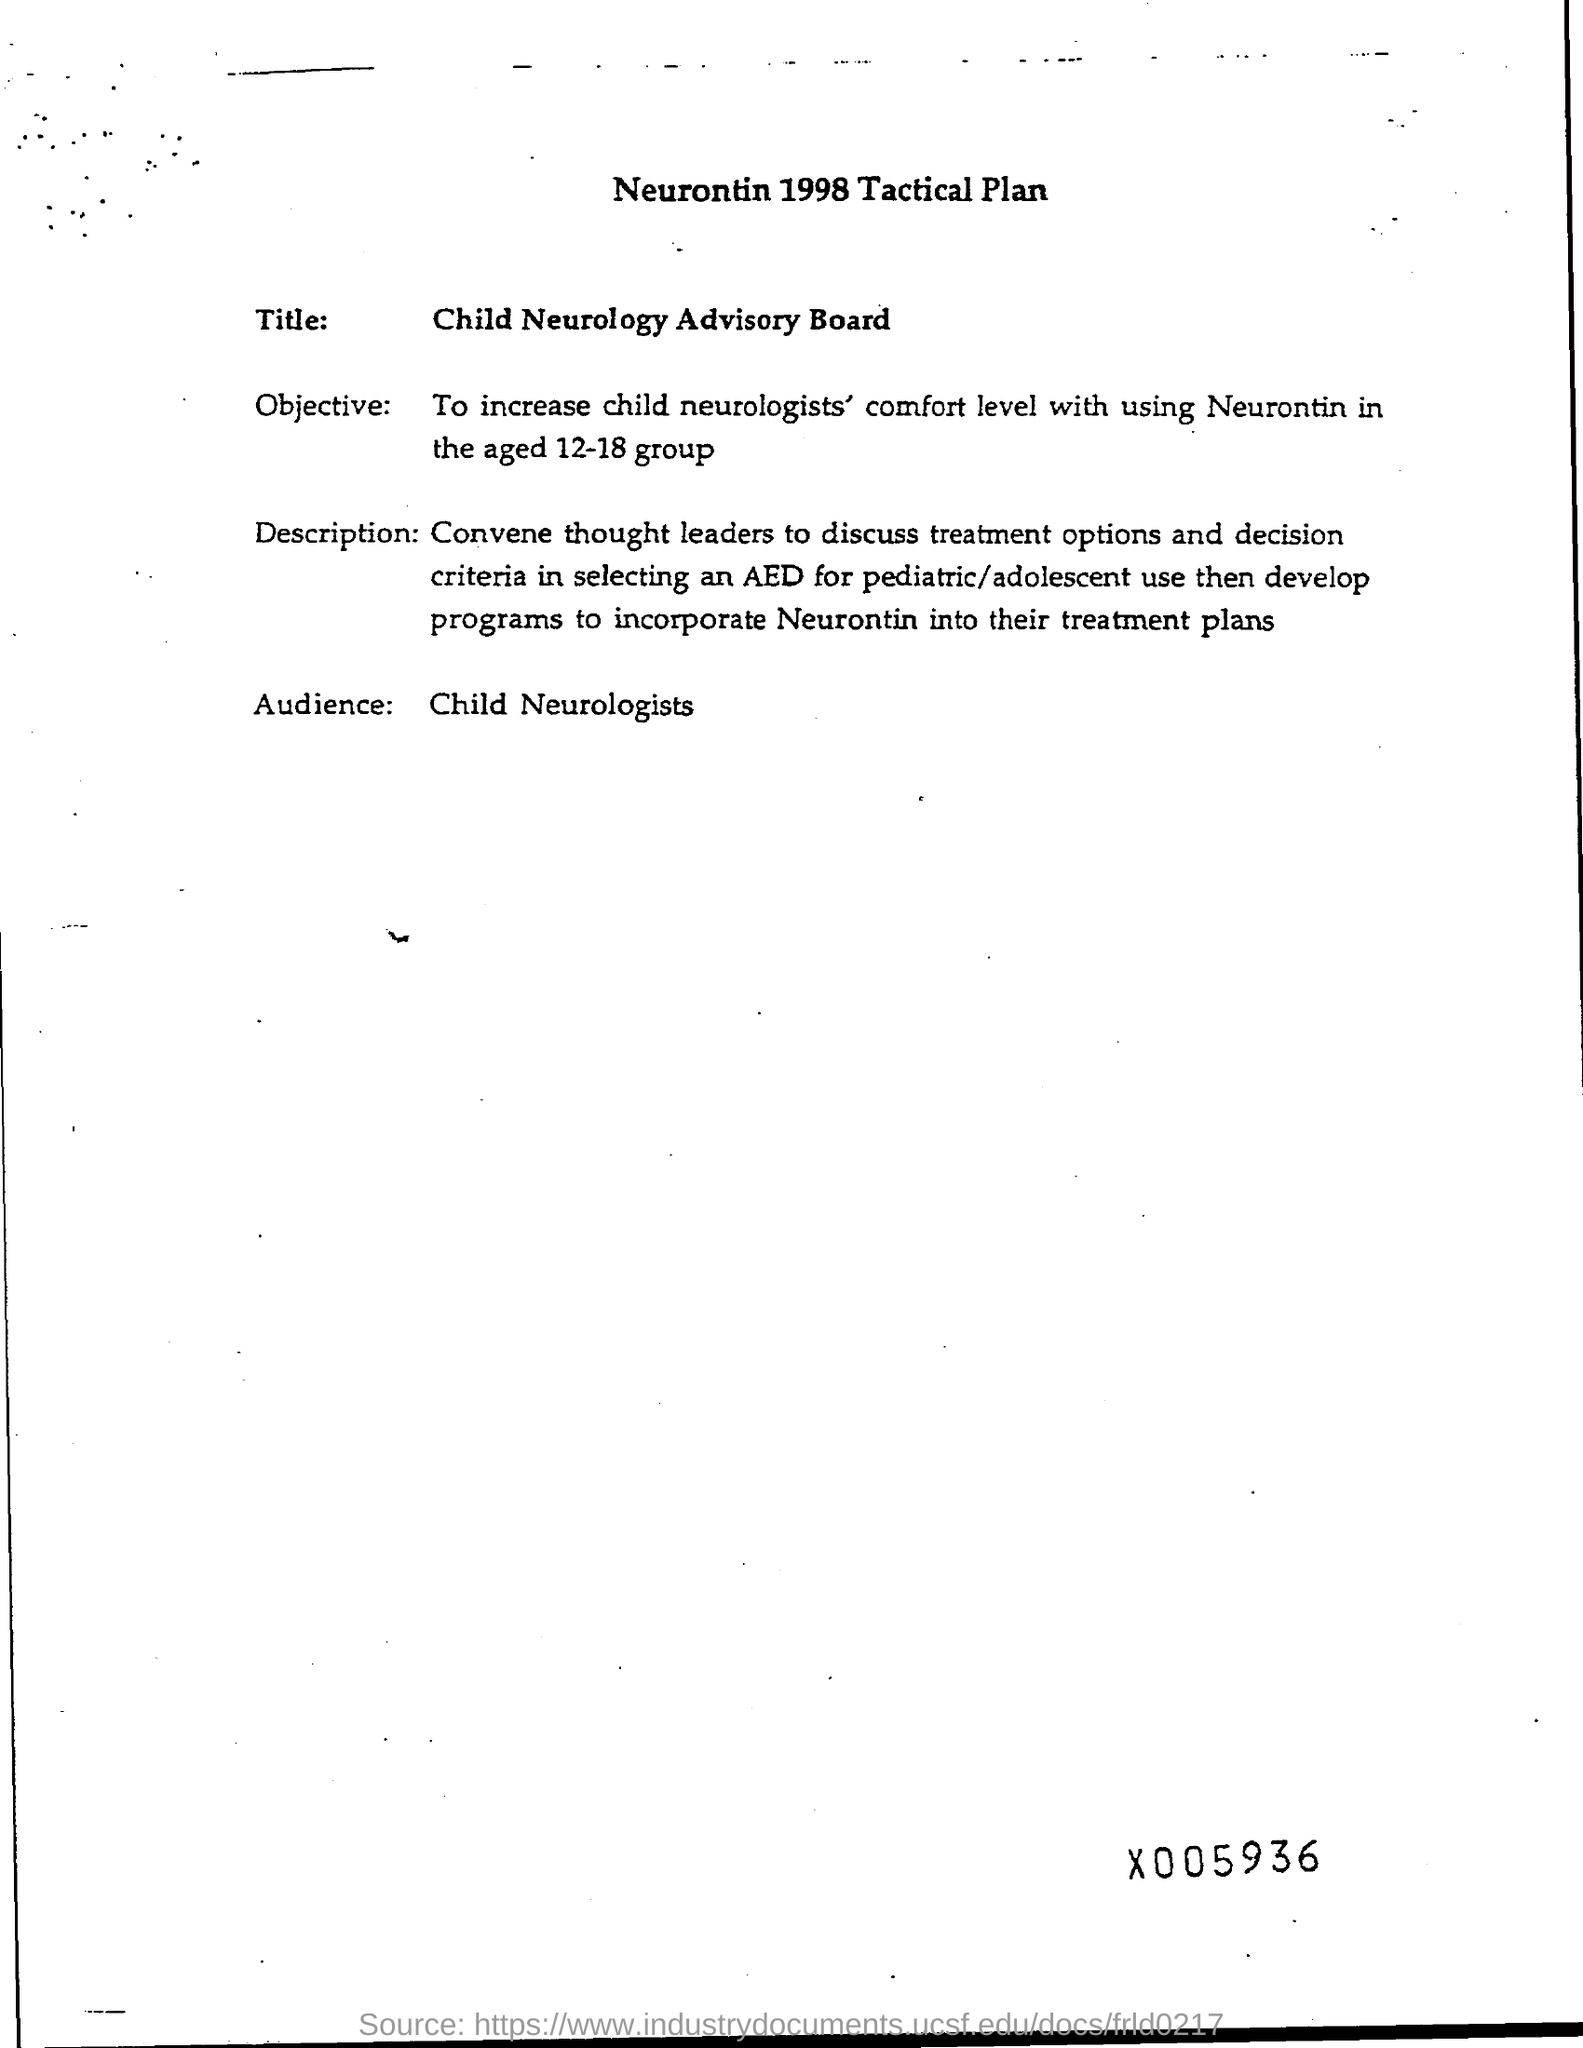Mention a couple of crucial points in this snapshot. The title of the document is "Child Neurology Advisory Board. The title of the page is Neurontin 1998 Tactical Plan. The audience consists of child neurologists. 